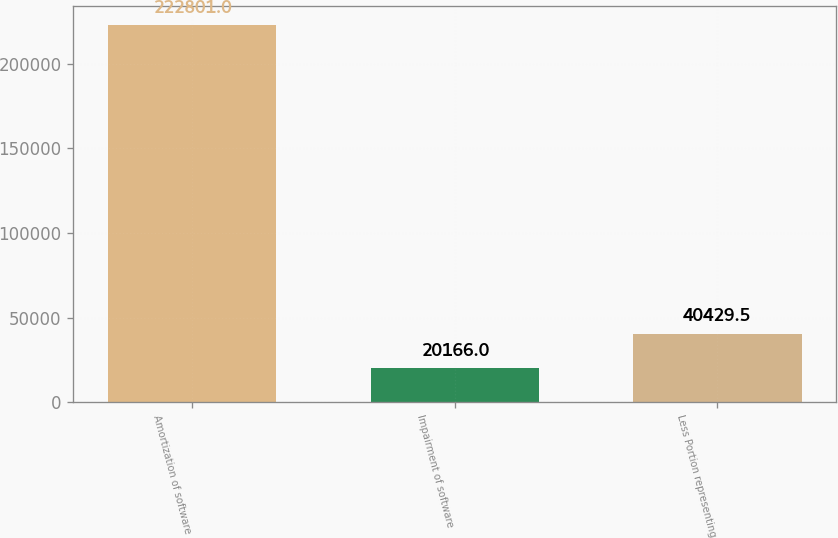Convert chart. <chart><loc_0><loc_0><loc_500><loc_500><bar_chart><fcel>Amortization of software<fcel>Impairment of software<fcel>Less Portion representing<nl><fcel>222801<fcel>20166<fcel>40429.5<nl></chart> 